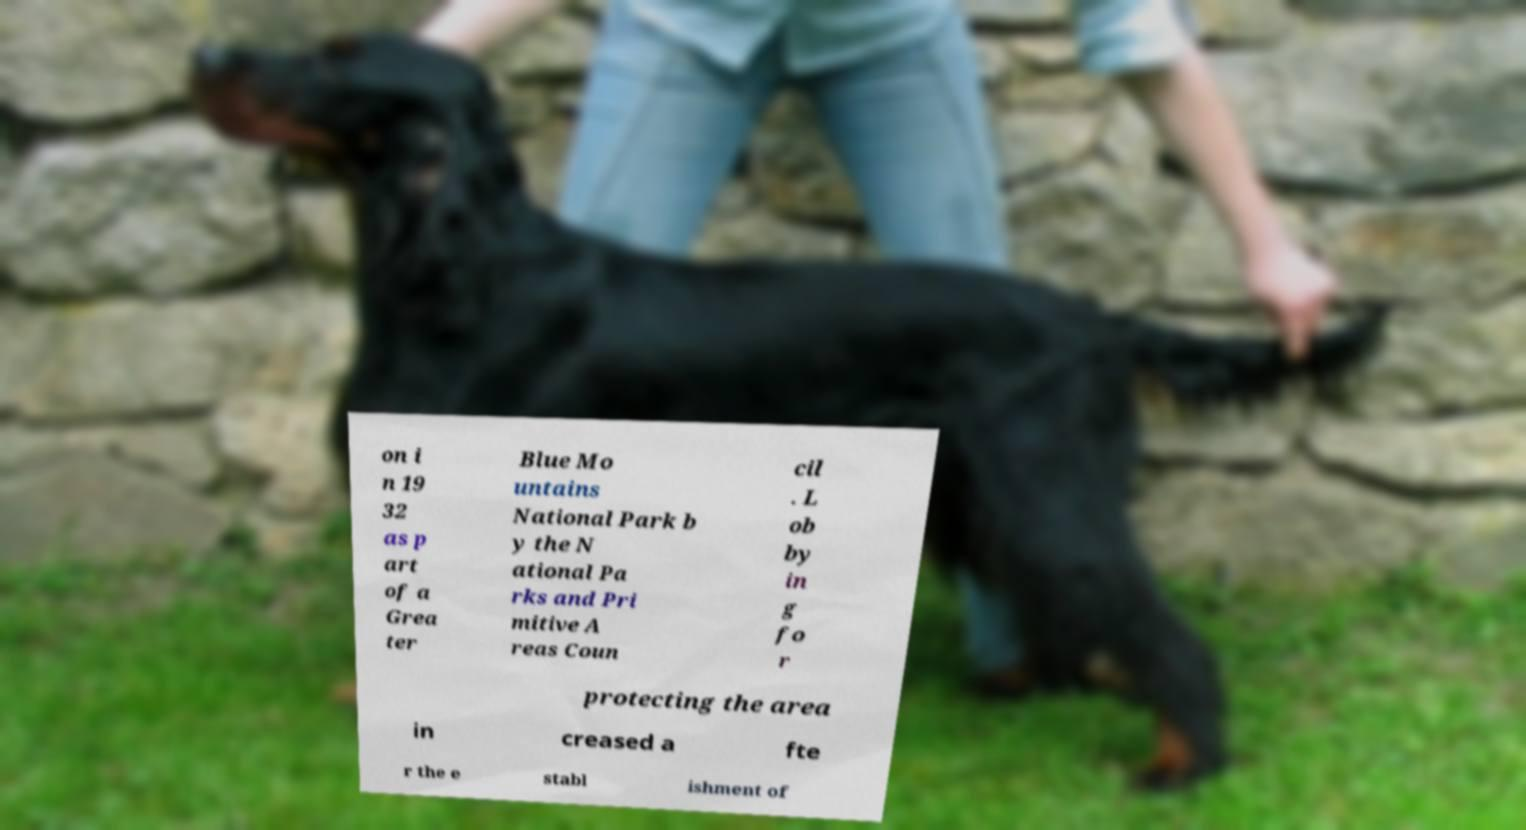Can you read and provide the text displayed in the image?This photo seems to have some interesting text. Can you extract and type it out for me? on i n 19 32 as p art of a Grea ter Blue Mo untains National Park b y the N ational Pa rks and Pri mitive A reas Coun cil . L ob by in g fo r protecting the area in creased a fte r the e stabl ishment of 